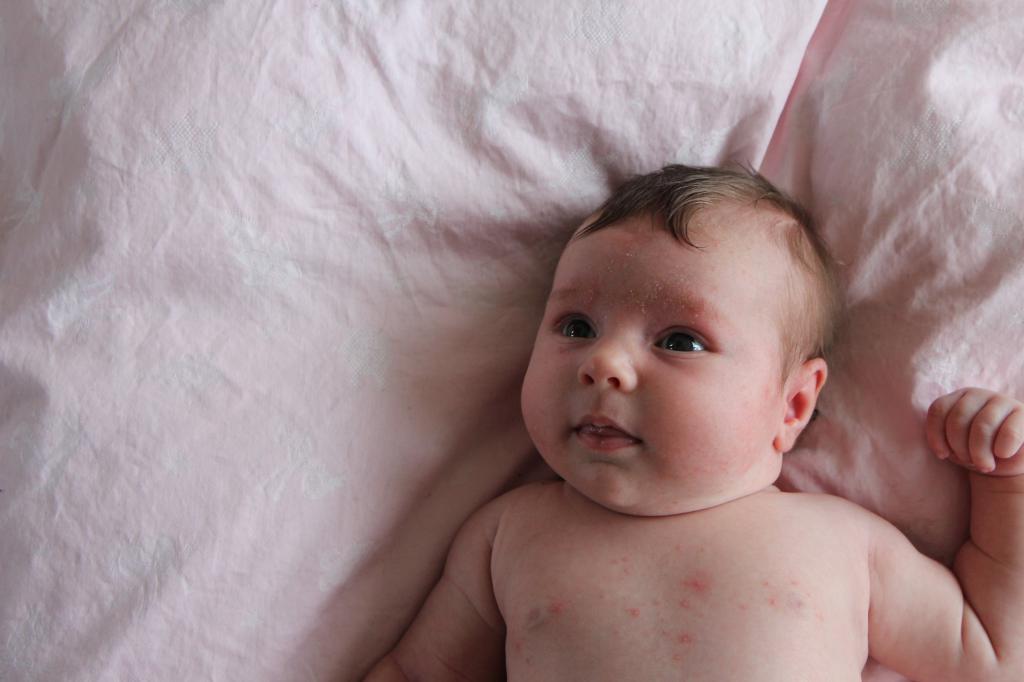Could you give a brief overview of what you see in this image? In this image I can see a baby is lying on a bed. This image is taken may be in a room. 